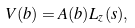<formula> <loc_0><loc_0><loc_500><loc_500>V ( b ) = A ( b ) L _ { z } ( s ) ,</formula> 